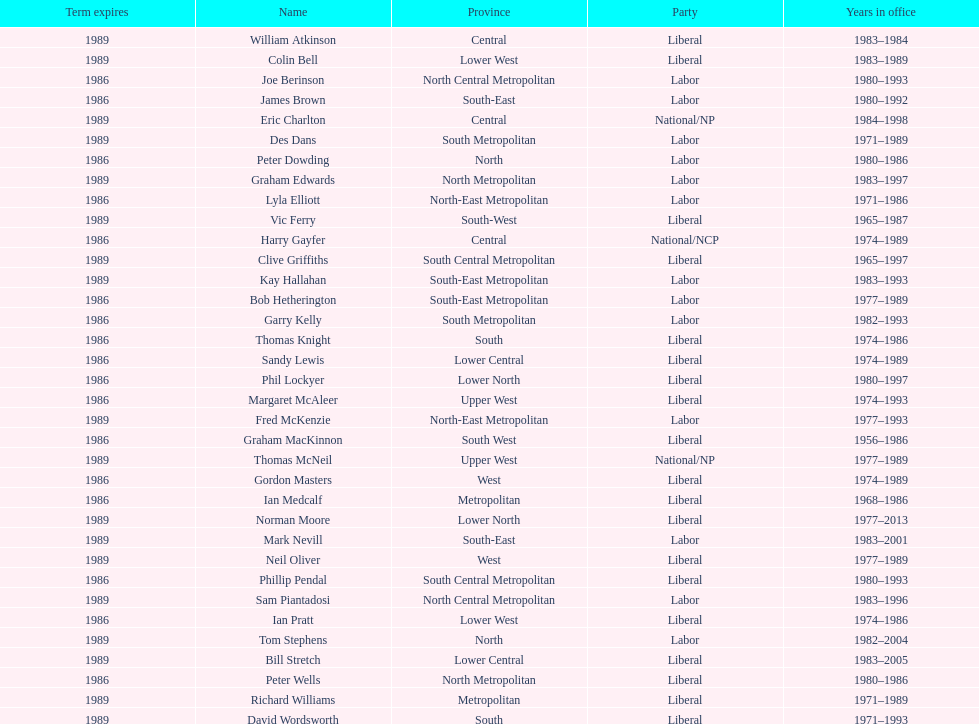Who has had the shortest term in office William Atkinson. 